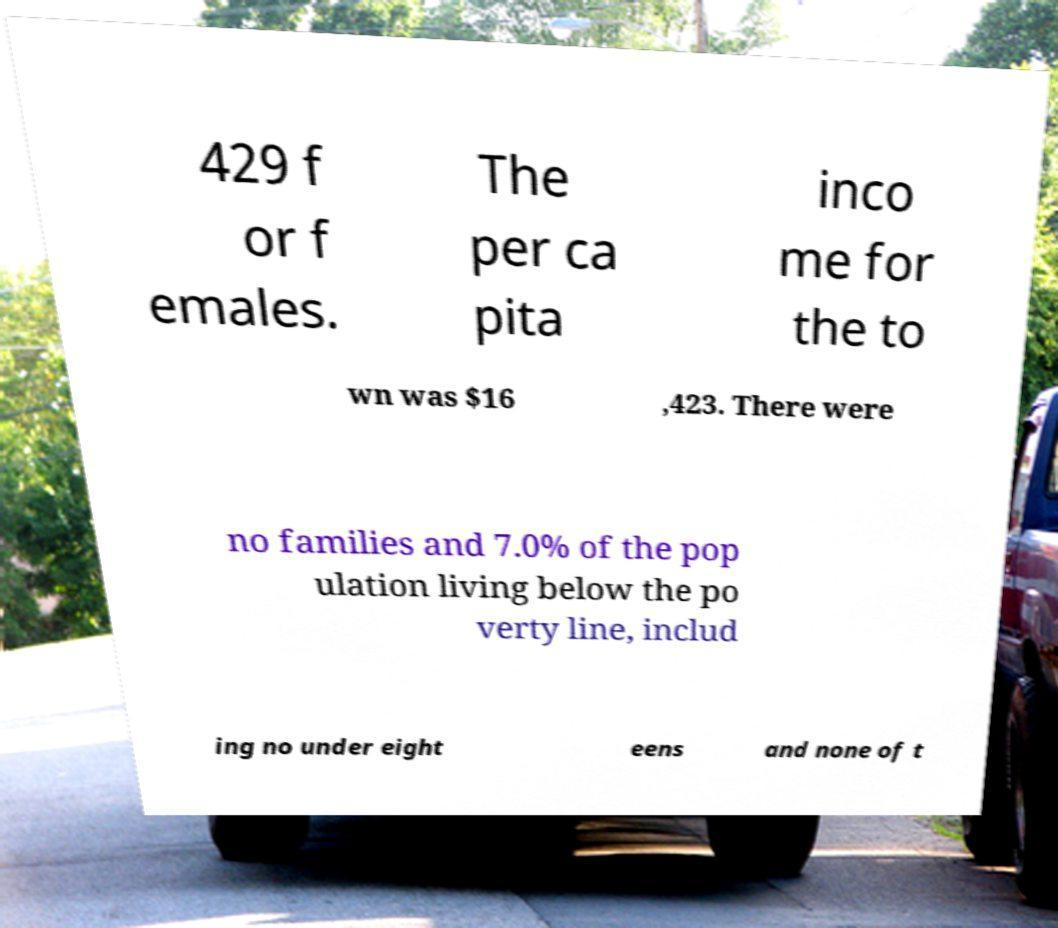For documentation purposes, I need the text within this image transcribed. Could you provide that? 429 f or f emales. The per ca pita inco me for the to wn was $16 ,423. There were no families and 7.0% of the pop ulation living below the po verty line, includ ing no under eight eens and none of t 